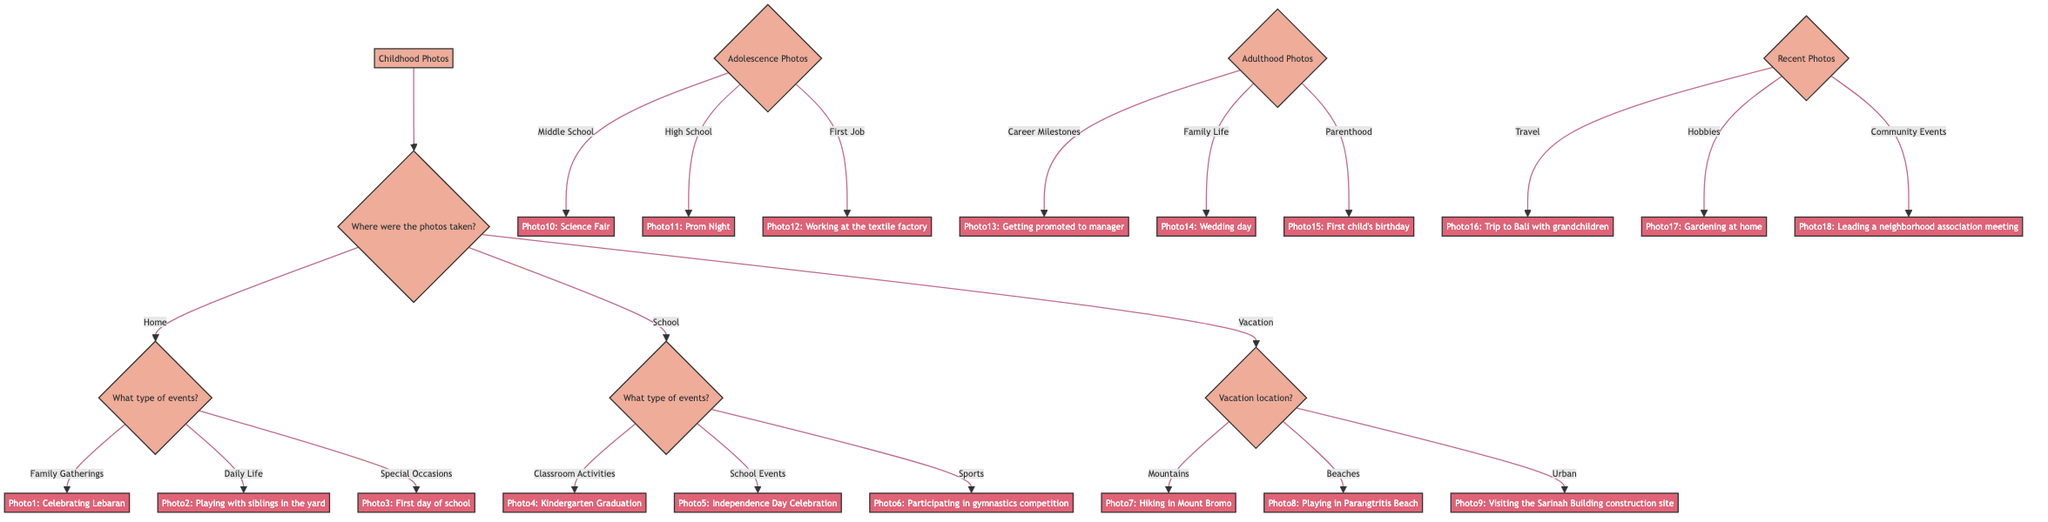What are the different locations where childhood photos were taken? The diagram lists three main locations under the "Where were the photos taken?" question, which are Home, School, and Vacation. Each location has further options explored in the flow of the diagram.
Answer: Home, School, Vacation What types of events are depicted under Home? The flow where "Home" is selected leads to "What type of events?" which lists three options: Family Gatherings, Daily Life, and Special Occasions, indicating the kinds of photos categorized under that location.
Answer: Family Gatherings, Daily Life, Special Occasions How many types of events are listed under School? Under the "School" decision, there are three types of events provided in response to the question "What type of events?", which are Classroom Activities, School Events, and Sports.
Answer: 3 What is the photo associated with a special occasion? Following the decision tree, under Home's events, the Special Occasions branch leads directly to "Photo3: First day of school." This is identified as a photo that represents a special occasion in childhood.
Answer: Photo3: First day of school Which photo is associated with visiting the Sarinah Building construction site? The diagram shows that when the Vacation location is Urban, it leads to "Photo9: Visiting the Sarinah Building construction site," clearly indicating the event and location associated with that photo.
Answer: Photo9: Visiting the Sarinah Building construction site What are the sections of photos represented in the diagram? The diagram is divided into four distinct sections of photos: Childhood Photos, Adolescence Photos, Adulthood Photos, and Recent Photos. Each section is distinguished by the overall theme and time period represented.
Answer: Childhood Photos, Adolescence Photos, Adulthood Photos, Recent Photos Which photo represents a career milestone? In the Adulthood Photos section, the option Career Milestones leads to "Photo13: Getting promoted to manager," which specifically represents a career achievement in adulthood.
Answer: Photo13: Getting promoted to manager What type of recent photo illustrates a hobby? Looking at the Recent Photos section, the Hobbies option leads to "Photo17: Gardening at home," which is directly categorized as a hobby-related photo among the possibilities in that section.
Answer: Photo17: Gardening at home 